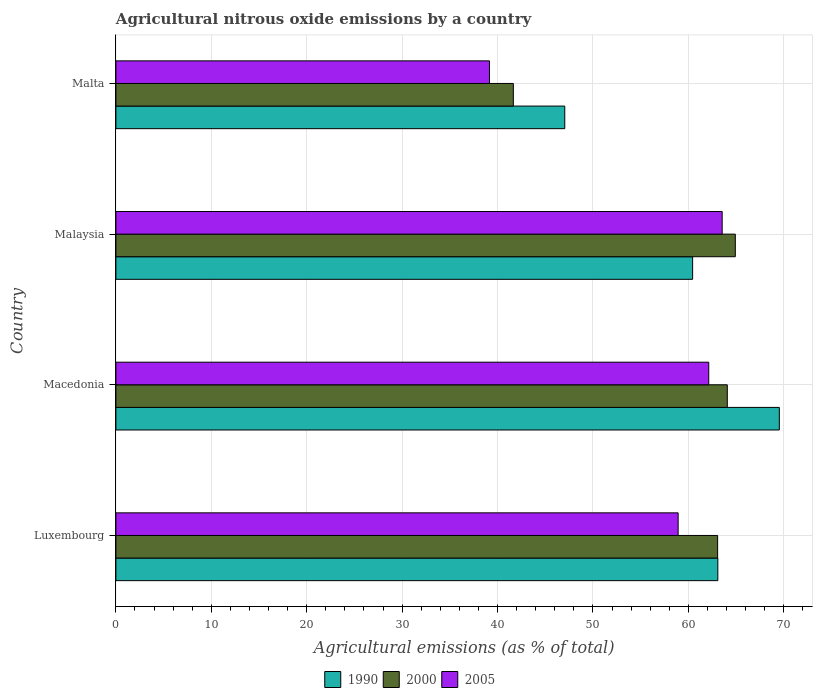How many different coloured bars are there?
Your answer should be compact. 3. How many groups of bars are there?
Your answer should be very brief. 4. Are the number of bars per tick equal to the number of legend labels?
Your answer should be compact. Yes. Are the number of bars on each tick of the Y-axis equal?
Provide a short and direct response. Yes. What is the label of the 2nd group of bars from the top?
Your answer should be very brief. Malaysia. In how many cases, is the number of bars for a given country not equal to the number of legend labels?
Provide a short and direct response. 0. What is the amount of agricultural nitrous oxide emitted in 2005 in Malta?
Keep it short and to the point. 39.15. Across all countries, what is the maximum amount of agricultural nitrous oxide emitted in 2005?
Your response must be concise. 63.54. Across all countries, what is the minimum amount of agricultural nitrous oxide emitted in 2005?
Offer a terse response. 39.15. In which country was the amount of agricultural nitrous oxide emitted in 1990 maximum?
Your answer should be compact. Macedonia. In which country was the amount of agricultural nitrous oxide emitted in 1990 minimum?
Make the answer very short. Malta. What is the total amount of agricultural nitrous oxide emitted in 2005 in the graph?
Your answer should be very brief. 223.75. What is the difference between the amount of agricultural nitrous oxide emitted in 2005 in Luxembourg and that in Malaysia?
Offer a very short reply. -4.61. What is the difference between the amount of agricultural nitrous oxide emitted in 2005 in Malaysia and the amount of agricultural nitrous oxide emitted in 2000 in Malta?
Ensure brevity in your answer.  21.89. What is the average amount of agricultural nitrous oxide emitted in 2000 per country?
Keep it short and to the point. 58.43. What is the difference between the amount of agricultural nitrous oxide emitted in 2000 and amount of agricultural nitrous oxide emitted in 2005 in Luxembourg?
Keep it short and to the point. 4.14. In how many countries, is the amount of agricultural nitrous oxide emitted in 2000 greater than 42 %?
Provide a short and direct response. 3. What is the ratio of the amount of agricultural nitrous oxide emitted in 2000 in Malaysia to that in Malta?
Make the answer very short. 1.56. Is the difference between the amount of agricultural nitrous oxide emitted in 2000 in Macedonia and Malta greater than the difference between the amount of agricultural nitrous oxide emitted in 2005 in Macedonia and Malta?
Make the answer very short. No. What is the difference between the highest and the second highest amount of agricultural nitrous oxide emitted in 2000?
Provide a succinct answer. 0.84. What is the difference between the highest and the lowest amount of agricultural nitrous oxide emitted in 2000?
Make the answer very short. 23.26. Is it the case that in every country, the sum of the amount of agricultural nitrous oxide emitted in 2000 and amount of agricultural nitrous oxide emitted in 2005 is greater than the amount of agricultural nitrous oxide emitted in 1990?
Ensure brevity in your answer.  Yes. Are all the bars in the graph horizontal?
Ensure brevity in your answer.  Yes. How many legend labels are there?
Your answer should be very brief. 3. What is the title of the graph?
Provide a succinct answer. Agricultural nitrous oxide emissions by a country. Does "1989" appear as one of the legend labels in the graph?
Your answer should be very brief. No. What is the label or title of the X-axis?
Offer a terse response. Agricultural emissions (as % of total). What is the Agricultural emissions (as % of total) of 1990 in Luxembourg?
Make the answer very short. 63.08. What is the Agricultural emissions (as % of total) of 2000 in Luxembourg?
Your answer should be compact. 63.06. What is the Agricultural emissions (as % of total) of 2005 in Luxembourg?
Give a very brief answer. 58.93. What is the Agricultural emissions (as % of total) in 1990 in Macedonia?
Keep it short and to the point. 69.53. What is the Agricultural emissions (as % of total) in 2000 in Macedonia?
Provide a succinct answer. 64.08. What is the Agricultural emissions (as % of total) in 2005 in Macedonia?
Your answer should be very brief. 62.13. What is the Agricultural emissions (as % of total) of 1990 in Malaysia?
Your response must be concise. 60.44. What is the Agricultural emissions (as % of total) of 2000 in Malaysia?
Your answer should be compact. 64.92. What is the Agricultural emissions (as % of total) in 2005 in Malaysia?
Provide a succinct answer. 63.54. What is the Agricultural emissions (as % of total) in 1990 in Malta?
Ensure brevity in your answer.  47.04. What is the Agricultural emissions (as % of total) in 2000 in Malta?
Offer a terse response. 41.65. What is the Agricultural emissions (as % of total) of 2005 in Malta?
Ensure brevity in your answer.  39.15. Across all countries, what is the maximum Agricultural emissions (as % of total) in 1990?
Provide a short and direct response. 69.53. Across all countries, what is the maximum Agricultural emissions (as % of total) in 2000?
Keep it short and to the point. 64.92. Across all countries, what is the maximum Agricultural emissions (as % of total) of 2005?
Offer a terse response. 63.54. Across all countries, what is the minimum Agricultural emissions (as % of total) in 1990?
Give a very brief answer. 47.04. Across all countries, what is the minimum Agricultural emissions (as % of total) of 2000?
Provide a succinct answer. 41.65. Across all countries, what is the minimum Agricultural emissions (as % of total) in 2005?
Offer a very short reply. 39.15. What is the total Agricultural emissions (as % of total) of 1990 in the graph?
Ensure brevity in your answer.  240.1. What is the total Agricultural emissions (as % of total) of 2000 in the graph?
Ensure brevity in your answer.  233.71. What is the total Agricultural emissions (as % of total) of 2005 in the graph?
Ensure brevity in your answer.  223.75. What is the difference between the Agricultural emissions (as % of total) in 1990 in Luxembourg and that in Macedonia?
Your answer should be very brief. -6.45. What is the difference between the Agricultural emissions (as % of total) in 2000 in Luxembourg and that in Macedonia?
Provide a succinct answer. -1.01. What is the difference between the Agricultural emissions (as % of total) of 2005 in Luxembourg and that in Macedonia?
Make the answer very short. -3.21. What is the difference between the Agricultural emissions (as % of total) of 1990 in Luxembourg and that in Malaysia?
Make the answer very short. 2.64. What is the difference between the Agricultural emissions (as % of total) in 2000 in Luxembourg and that in Malaysia?
Your answer should be very brief. -1.85. What is the difference between the Agricultural emissions (as % of total) in 2005 in Luxembourg and that in Malaysia?
Your response must be concise. -4.61. What is the difference between the Agricultural emissions (as % of total) of 1990 in Luxembourg and that in Malta?
Offer a very short reply. 16.04. What is the difference between the Agricultural emissions (as % of total) of 2000 in Luxembourg and that in Malta?
Your answer should be compact. 21.41. What is the difference between the Agricultural emissions (as % of total) in 2005 in Luxembourg and that in Malta?
Your answer should be very brief. 19.77. What is the difference between the Agricultural emissions (as % of total) in 1990 in Macedonia and that in Malaysia?
Provide a succinct answer. 9.09. What is the difference between the Agricultural emissions (as % of total) of 2000 in Macedonia and that in Malaysia?
Your answer should be very brief. -0.84. What is the difference between the Agricultural emissions (as % of total) of 2005 in Macedonia and that in Malaysia?
Provide a succinct answer. -1.41. What is the difference between the Agricultural emissions (as % of total) of 1990 in Macedonia and that in Malta?
Your answer should be compact. 22.49. What is the difference between the Agricultural emissions (as % of total) of 2000 in Macedonia and that in Malta?
Ensure brevity in your answer.  22.42. What is the difference between the Agricultural emissions (as % of total) of 2005 in Macedonia and that in Malta?
Ensure brevity in your answer.  22.98. What is the difference between the Agricultural emissions (as % of total) of 1990 in Malaysia and that in Malta?
Your response must be concise. 13.4. What is the difference between the Agricultural emissions (as % of total) of 2000 in Malaysia and that in Malta?
Your answer should be compact. 23.26. What is the difference between the Agricultural emissions (as % of total) in 2005 in Malaysia and that in Malta?
Offer a terse response. 24.39. What is the difference between the Agricultural emissions (as % of total) of 1990 in Luxembourg and the Agricultural emissions (as % of total) of 2000 in Macedonia?
Offer a terse response. -0.99. What is the difference between the Agricultural emissions (as % of total) in 1990 in Luxembourg and the Agricultural emissions (as % of total) in 2005 in Macedonia?
Offer a very short reply. 0.95. What is the difference between the Agricultural emissions (as % of total) in 2000 in Luxembourg and the Agricultural emissions (as % of total) in 2005 in Macedonia?
Offer a terse response. 0.93. What is the difference between the Agricultural emissions (as % of total) in 1990 in Luxembourg and the Agricultural emissions (as % of total) in 2000 in Malaysia?
Ensure brevity in your answer.  -1.83. What is the difference between the Agricultural emissions (as % of total) in 1990 in Luxembourg and the Agricultural emissions (as % of total) in 2005 in Malaysia?
Your answer should be compact. -0.46. What is the difference between the Agricultural emissions (as % of total) of 2000 in Luxembourg and the Agricultural emissions (as % of total) of 2005 in Malaysia?
Make the answer very short. -0.48. What is the difference between the Agricultural emissions (as % of total) of 1990 in Luxembourg and the Agricultural emissions (as % of total) of 2000 in Malta?
Your answer should be very brief. 21.43. What is the difference between the Agricultural emissions (as % of total) of 1990 in Luxembourg and the Agricultural emissions (as % of total) of 2005 in Malta?
Your response must be concise. 23.93. What is the difference between the Agricultural emissions (as % of total) of 2000 in Luxembourg and the Agricultural emissions (as % of total) of 2005 in Malta?
Provide a succinct answer. 23.91. What is the difference between the Agricultural emissions (as % of total) of 1990 in Macedonia and the Agricultural emissions (as % of total) of 2000 in Malaysia?
Offer a terse response. 4.61. What is the difference between the Agricultural emissions (as % of total) of 1990 in Macedonia and the Agricultural emissions (as % of total) of 2005 in Malaysia?
Your answer should be compact. 5.99. What is the difference between the Agricultural emissions (as % of total) of 2000 in Macedonia and the Agricultural emissions (as % of total) of 2005 in Malaysia?
Ensure brevity in your answer.  0.54. What is the difference between the Agricultural emissions (as % of total) in 1990 in Macedonia and the Agricultural emissions (as % of total) in 2000 in Malta?
Give a very brief answer. 27.88. What is the difference between the Agricultural emissions (as % of total) of 1990 in Macedonia and the Agricultural emissions (as % of total) of 2005 in Malta?
Offer a terse response. 30.38. What is the difference between the Agricultural emissions (as % of total) of 2000 in Macedonia and the Agricultural emissions (as % of total) of 2005 in Malta?
Make the answer very short. 24.92. What is the difference between the Agricultural emissions (as % of total) of 1990 in Malaysia and the Agricultural emissions (as % of total) of 2000 in Malta?
Your answer should be very brief. 18.79. What is the difference between the Agricultural emissions (as % of total) of 1990 in Malaysia and the Agricultural emissions (as % of total) of 2005 in Malta?
Offer a very short reply. 21.29. What is the difference between the Agricultural emissions (as % of total) of 2000 in Malaysia and the Agricultural emissions (as % of total) of 2005 in Malta?
Provide a succinct answer. 25.76. What is the average Agricultural emissions (as % of total) in 1990 per country?
Provide a succinct answer. 60.03. What is the average Agricultural emissions (as % of total) of 2000 per country?
Your answer should be very brief. 58.43. What is the average Agricultural emissions (as % of total) in 2005 per country?
Give a very brief answer. 55.94. What is the difference between the Agricultural emissions (as % of total) in 1990 and Agricultural emissions (as % of total) in 2000 in Luxembourg?
Your answer should be very brief. 0.02. What is the difference between the Agricultural emissions (as % of total) in 1990 and Agricultural emissions (as % of total) in 2005 in Luxembourg?
Your answer should be compact. 4.16. What is the difference between the Agricultural emissions (as % of total) of 2000 and Agricultural emissions (as % of total) of 2005 in Luxembourg?
Offer a terse response. 4.14. What is the difference between the Agricultural emissions (as % of total) in 1990 and Agricultural emissions (as % of total) in 2000 in Macedonia?
Your answer should be compact. 5.45. What is the difference between the Agricultural emissions (as % of total) in 1990 and Agricultural emissions (as % of total) in 2005 in Macedonia?
Make the answer very short. 7.4. What is the difference between the Agricultural emissions (as % of total) of 2000 and Agricultural emissions (as % of total) of 2005 in Macedonia?
Offer a terse response. 1.95. What is the difference between the Agricultural emissions (as % of total) of 1990 and Agricultural emissions (as % of total) of 2000 in Malaysia?
Your answer should be compact. -4.47. What is the difference between the Agricultural emissions (as % of total) of 1990 and Agricultural emissions (as % of total) of 2005 in Malaysia?
Offer a terse response. -3.1. What is the difference between the Agricultural emissions (as % of total) in 2000 and Agricultural emissions (as % of total) in 2005 in Malaysia?
Offer a very short reply. 1.38. What is the difference between the Agricultural emissions (as % of total) in 1990 and Agricultural emissions (as % of total) in 2000 in Malta?
Give a very brief answer. 5.39. What is the difference between the Agricultural emissions (as % of total) of 1990 and Agricultural emissions (as % of total) of 2005 in Malta?
Offer a very short reply. 7.89. What is the difference between the Agricultural emissions (as % of total) of 2000 and Agricultural emissions (as % of total) of 2005 in Malta?
Make the answer very short. 2.5. What is the ratio of the Agricultural emissions (as % of total) in 1990 in Luxembourg to that in Macedonia?
Make the answer very short. 0.91. What is the ratio of the Agricultural emissions (as % of total) of 2000 in Luxembourg to that in Macedonia?
Your answer should be very brief. 0.98. What is the ratio of the Agricultural emissions (as % of total) in 2005 in Luxembourg to that in Macedonia?
Give a very brief answer. 0.95. What is the ratio of the Agricultural emissions (as % of total) of 1990 in Luxembourg to that in Malaysia?
Keep it short and to the point. 1.04. What is the ratio of the Agricultural emissions (as % of total) in 2000 in Luxembourg to that in Malaysia?
Your response must be concise. 0.97. What is the ratio of the Agricultural emissions (as % of total) in 2005 in Luxembourg to that in Malaysia?
Offer a very short reply. 0.93. What is the ratio of the Agricultural emissions (as % of total) of 1990 in Luxembourg to that in Malta?
Offer a terse response. 1.34. What is the ratio of the Agricultural emissions (as % of total) in 2000 in Luxembourg to that in Malta?
Provide a short and direct response. 1.51. What is the ratio of the Agricultural emissions (as % of total) of 2005 in Luxembourg to that in Malta?
Give a very brief answer. 1.5. What is the ratio of the Agricultural emissions (as % of total) in 1990 in Macedonia to that in Malaysia?
Your response must be concise. 1.15. What is the ratio of the Agricultural emissions (as % of total) of 2000 in Macedonia to that in Malaysia?
Make the answer very short. 0.99. What is the ratio of the Agricultural emissions (as % of total) in 2005 in Macedonia to that in Malaysia?
Offer a very short reply. 0.98. What is the ratio of the Agricultural emissions (as % of total) in 1990 in Macedonia to that in Malta?
Give a very brief answer. 1.48. What is the ratio of the Agricultural emissions (as % of total) of 2000 in Macedonia to that in Malta?
Offer a terse response. 1.54. What is the ratio of the Agricultural emissions (as % of total) of 2005 in Macedonia to that in Malta?
Your answer should be compact. 1.59. What is the ratio of the Agricultural emissions (as % of total) in 1990 in Malaysia to that in Malta?
Ensure brevity in your answer.  1.28. What is the ratio of the Agricultural emissions (as % of total) of 2000 in Malaysia to that in Malta?
Give a very brief answer. 1.56. What is the ratio of the Agricultural emissions (as % of total) in 2005 in Malaysia to that in Malta?
Keep it short and to the point. 1.62. What is the difference between the highest and the second highest Agricultural emissions (as % of total) of 1990?
Offer a very short reply. 6.45. What is the difference between the highest and the second highest Agricultural emissions (as % of total) in 2000?
Offer a terse response. 0.84. What is the difference between the highest and the second highest Agricultural emissions (as % of total) of 2005?
Offer a very short reply. 1.41. What is the difference between the highest and the lowest Agricultural emissions (as % of total) in 1990?
Offer a very short reply. 22.49. What is the difference between the highest and the lowest Agricultural emissions (as % of total) of 2000?
Your answer should be very brief. 23.26. What is the difference between the highest and the lowest Agricultural emissions (as % of total) in 2005?
Give a very brief answer. 24.39. 